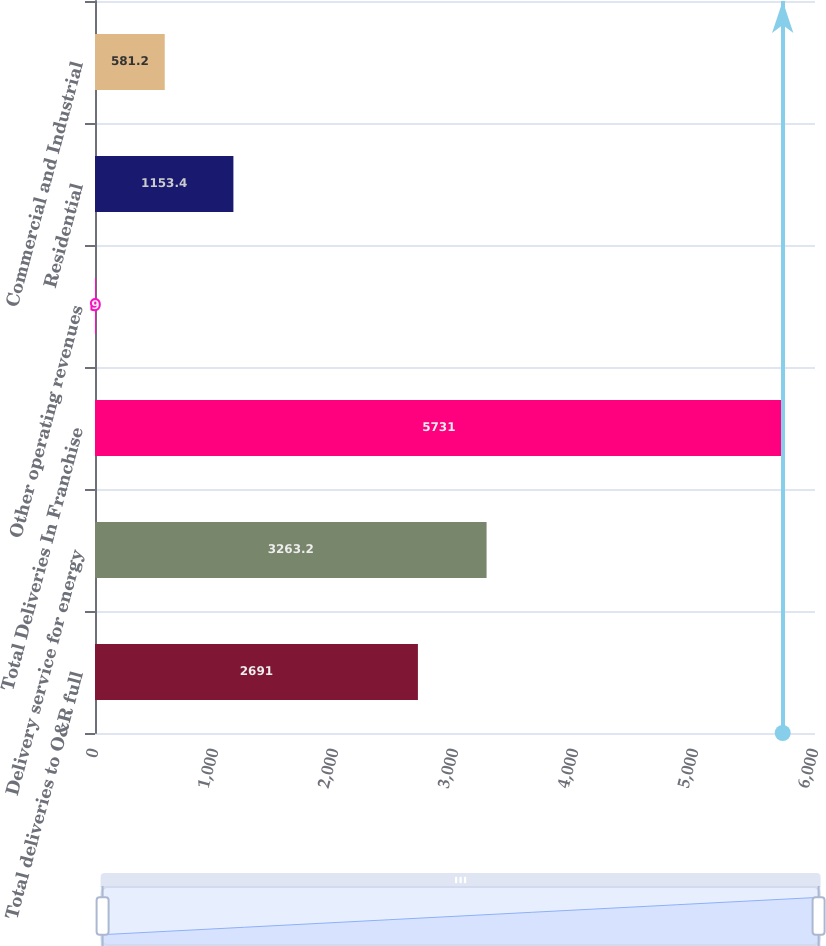<chart> <loc_0><loc_0><loc_500><loc_500><bar_chart><fcel>Total deliveries to O&R full<fcel>Delivery service for energy<fcel>Total Deliveries In Franchise<fcel>Other operating revenues<fcel>Residential<fcel>Commercial and Industrial<nl><fcel>2691<fcel>3263.2<fcel>5731<fcel>9<fcel>1153.4<fcel>581.2<nl></chart> 